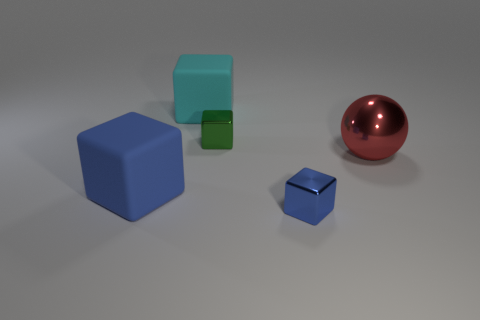Subtract all large blue cubes. How many cubes are left? 3 Add 2 blue objects. How many objects exist? 7 Subtract all green blocks. How many blocks are left? 3 Subtract all blue cylinders. How many blue blocks are left? 2 Subtract all balls. How many objects are left? 4 Subtract all cyan metallic cubes. Subtract all green objects. How many objects are left? 4 Add 1 blue shiny objects. How many blue shiny objects are left? 2 Add 5 metal objects. How many metal objects exist? 8 Subtract 0 green spheres. How many objects are left? 5 Subtract 1 cubes. How many cubes are left? 3 